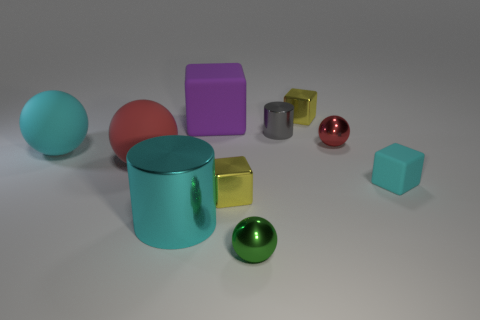What number of big rubber balls have the same color as the large metallic cylinder?
Provide a short and direct response. 1. Does the small object left of the green metallic ball have the same color as the small cube behind the tiny cyan cube?
Keep it short and to the point. Yes. The big metal thing that is the same color as the tiny rubber thing is what shape?
Your response must be concise. Cylinder. Do the red matte ball and the rubber block in front of the large red ball have the same size?
Provide a succinct answer. No. There is a cylinder that is the same material as the gray thing; what size is it?
Make the answer very short. Large. Is the number of red rubber things less than the number of large blue metallic blocks?
Make the answer very short. No. Is there any other thing that has the same color as the big metallic object?
Keep it short and to the point. Yes. The tiny red object that is made of the same material as the gray thing is what shape?
Provide a succinct answer. Sphere. There is a yellow metal block that is in front of the metallic block that is behind the big purple matte thing; how many yellow things are behind it?
Keep it short and to the point. 1. There is a object that is behind the large cyan rubber thing and left of the gray shiny cylinder; what shape is it?
Keep it short and to the point. Cube. 